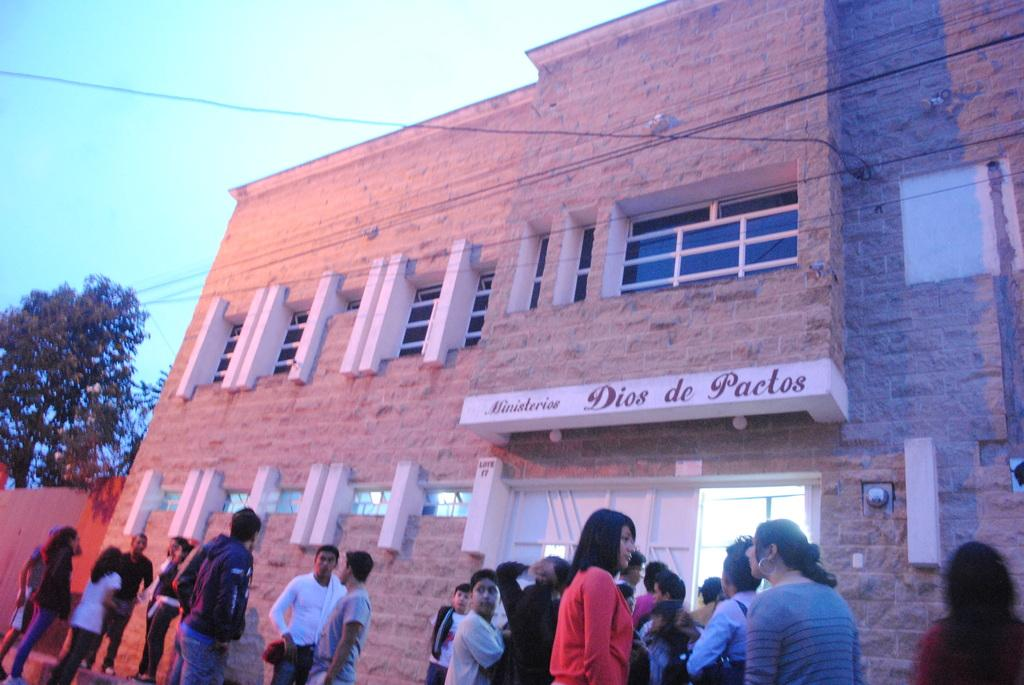Who or what can be seen in the image? There are people in the image. What object is present in the image that might be used for displaying information or announcements? There is a board in the image. What architectural feature is visible in the image that allows natural light to enter the space? There are windows in the image. What type of vegetation can be seen in the image? There are trees in the image. What type of structure is visible in the image? There is a building in the image. What can be seen in the background of the image? The sky is visible in the background of the image. What type of desk can be seen in the image? There is no desk present in the image. What type of wire is being used to connect the people in the image? There is no wire connecting the people in the image. 